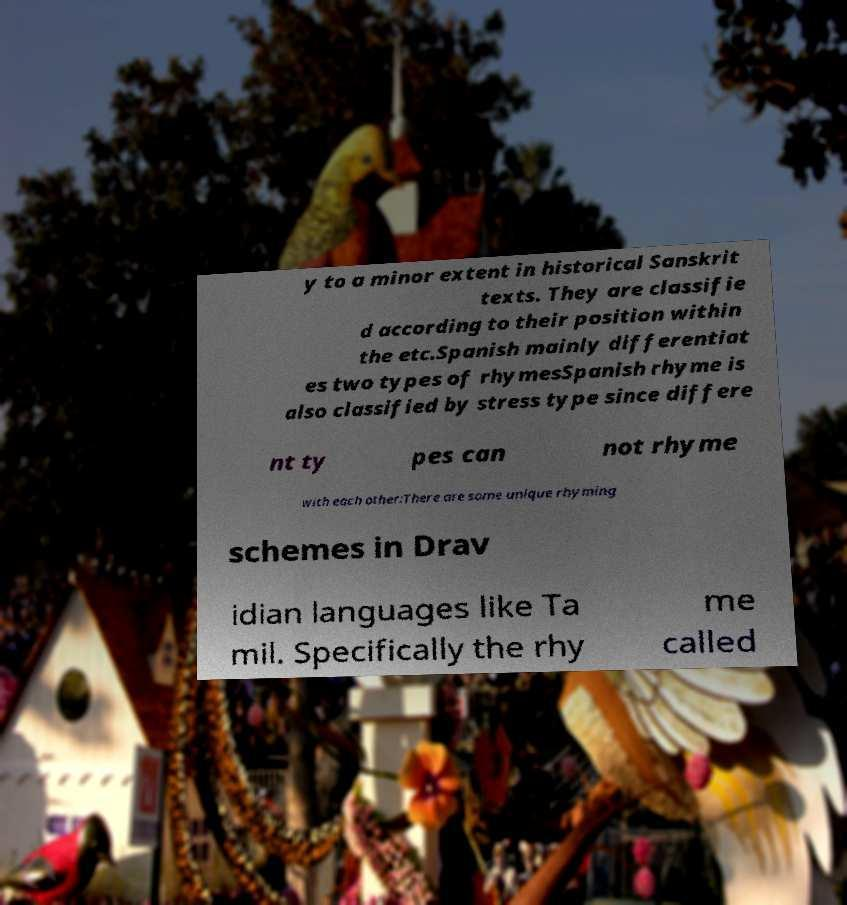Could you assist in decoding the text presented in this image and type it out clearly? y to a minor extent in historical Sanskrit texts. They are classifie d according to their position within the etc.Spanish mainly differentiat es two types of rhymesSpanish rhyme is also classified by stress type since differe nt ty pes can not rhyme with each other:There are some unique rhyming schemes in Drav idian languages like Ta mil. Specifically the rhy me called 